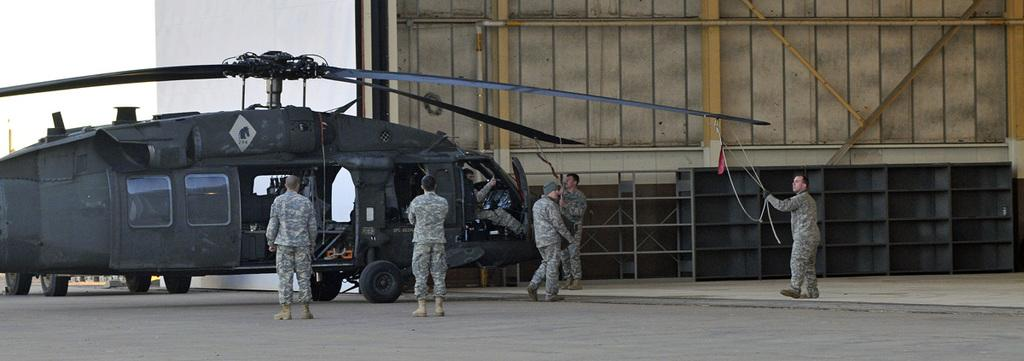What is the main subject of the image? The main subject of the image is a helicopter. Are there any people in the image? Yes, there are people in the image. What can be seen besides the helicopter and people? There are racks in the image. What is the position of one of the people in the image? One person is sitting inside the helicopter. What type of zinc can be seen on the helicopter in the image? There is no zinc present on the helicopter in the image. How many bottles are visible in the image? There are no bottles visible in the image. 